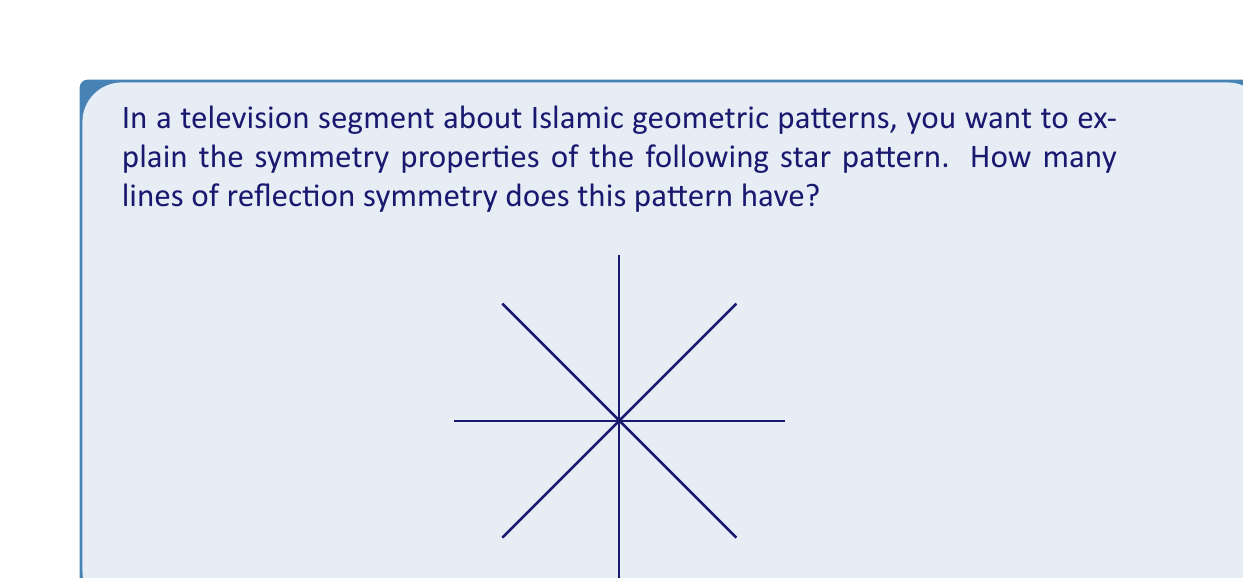Teach me how to tackle this problem. To determine the number of lines of reflection symmetry in this Islamic star pattern, we need to analyze its structure step-by-step:

1) First, observe that the pattern consists of an 8-pointed star.

2) In general, an n-pointed regular star has n lines of reflection symmetry.

3) These lines of symmetry pass through:
   a) The center of the star and each point of the star
   b) The center of the star and the midpoint between adjacent star points

4) For our 8-pointed star:
   - There are 8 lines passing through the center and each point
   - There are 8 lines passing through the center and the midpoint between adjacent points

5) However, due to the star's symmetry, these two sets of lines actually coincide.

6) To visualize this, imagine folding the pattern along any of these lines. The pattern would perfectly overlap itself, demonstrating reflection symmetry.

7) Therefore, the total number of unique lines of reflection symmetry is 8.

This concept can be easily explained to a television audience by physically folding a paper model of the pattern along these lines, visually demonstrating the symmetry.
Answer: 8 lines of reflection symmetry 